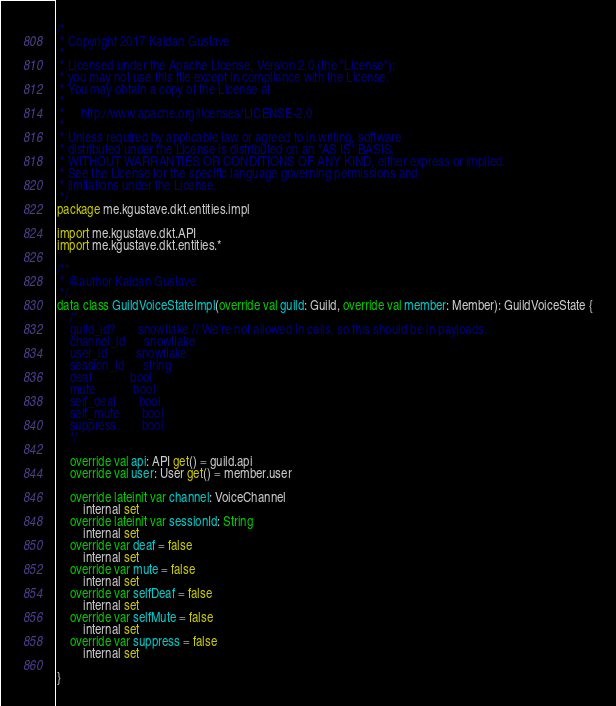Convert code to text. <code><loc_0><loc_0><loc_500><loc_500><_Kotlin_>/*
 * Copyright 2017 Kaidan Gustave
 *
 * Licensed under the Apache License, Version 2.0 (the "License");
 * you may not use this file except in compliance with the License.
 * You may obtain a copy of the License at
 *
 *     http://www.apache.org/licenses/LICENSE-2.0
 *
 * Unless required by applicable law or agreed to in writing, software
 * distributed under the License is distributed on an "AS IS" BASIS,
 * WITHOUT WARRANTIES OR CONDITIONS OF ANY KIND, either express or implied.
 * See the License for the specific language governing permissions and
 * limitations under the License.
 */
package me.kgustave.dkt.entities.impl

import me.kgustave.dkt.API
import me.kgustave.dkt.entities.*

/**
 * @author Kaidan Gustave
 */
data class GuildVoiceStateImpl(override val guild: Guild, override val member: Member): GuildVoiceState {
    /*
    guild_id?       snowflake // We're not allowed in calls, so this should be in payloads.
    channel_id      snowflake
    user_id         snowflake
    session_id      string
    deaf            bool
    mute            bool
    self_deaf       bool
    self_mute       bool
    suppress        bool
    */

    override val api: API get() = guild.api
    override val user: User get() = member.user

    override lateinit var channel: VoiceChannel
        internal set
    override lateinit var sessionId: String
        internal set
    override var deaf = false
        internal set
    override var mute = false
        internal set
    override var selfDeaf = false
        internal set
    override var selfMute = false
        internal set
    override var suppress = false
        internal set

}
</code> 